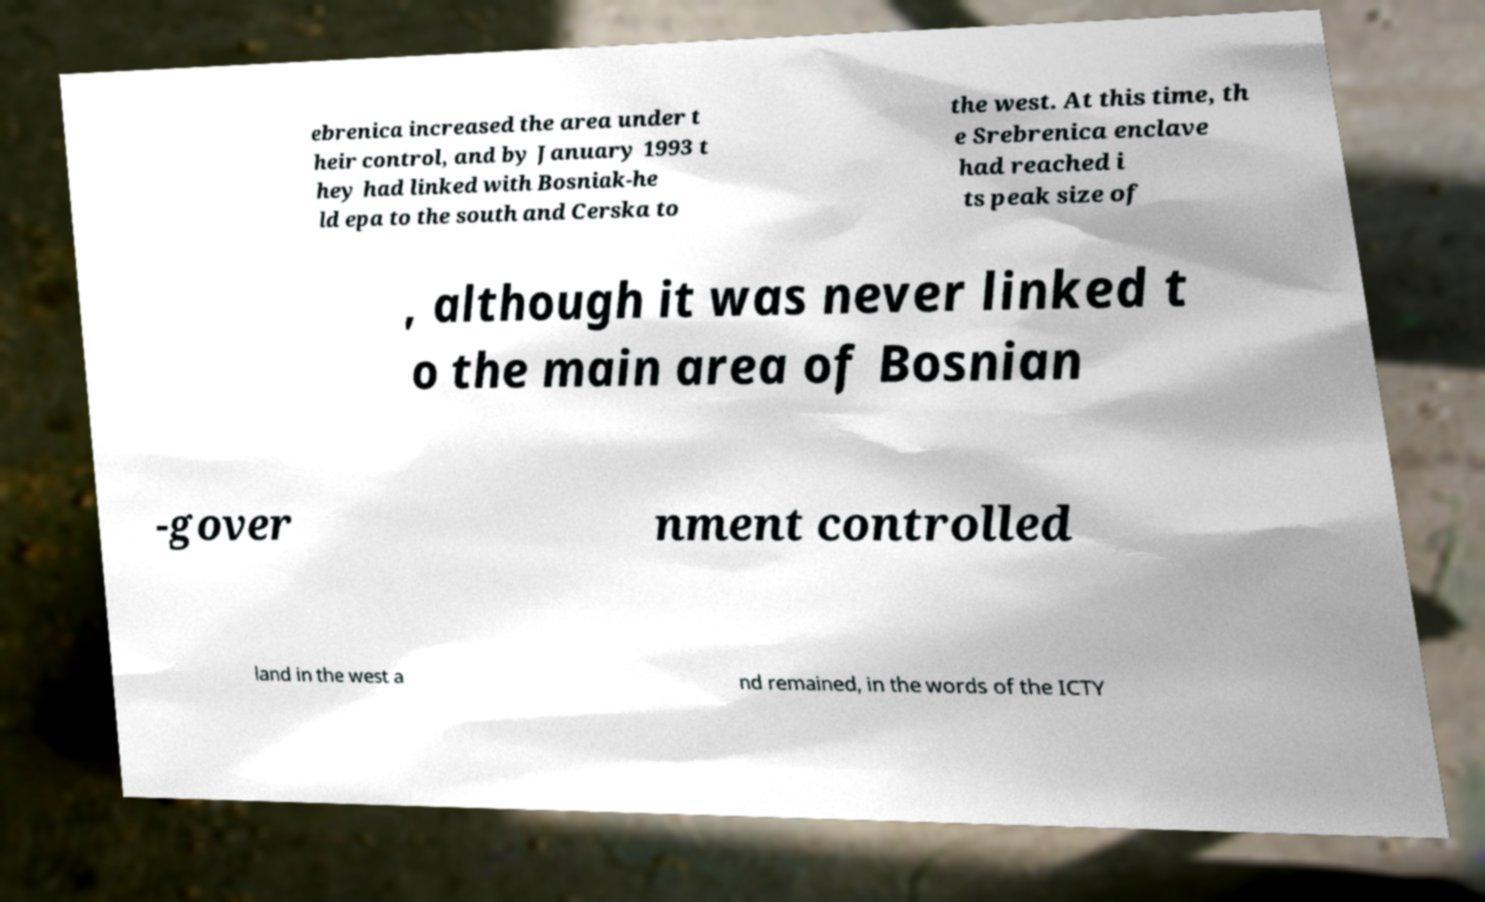What messages or text are displayed in this image? I need them in a readable, typed format. ebrenica increased the area under t heir control, and by January 1993 t hey had linked with Bosniak-he ld epa to the south and Cerska to the west. At this time, th e Srebrenica enclave had reached i ts peak size of , although it was never linked t o the main area of Bosnian -gover nment controlled land in the west a nd remained, in the words of the ICTY 